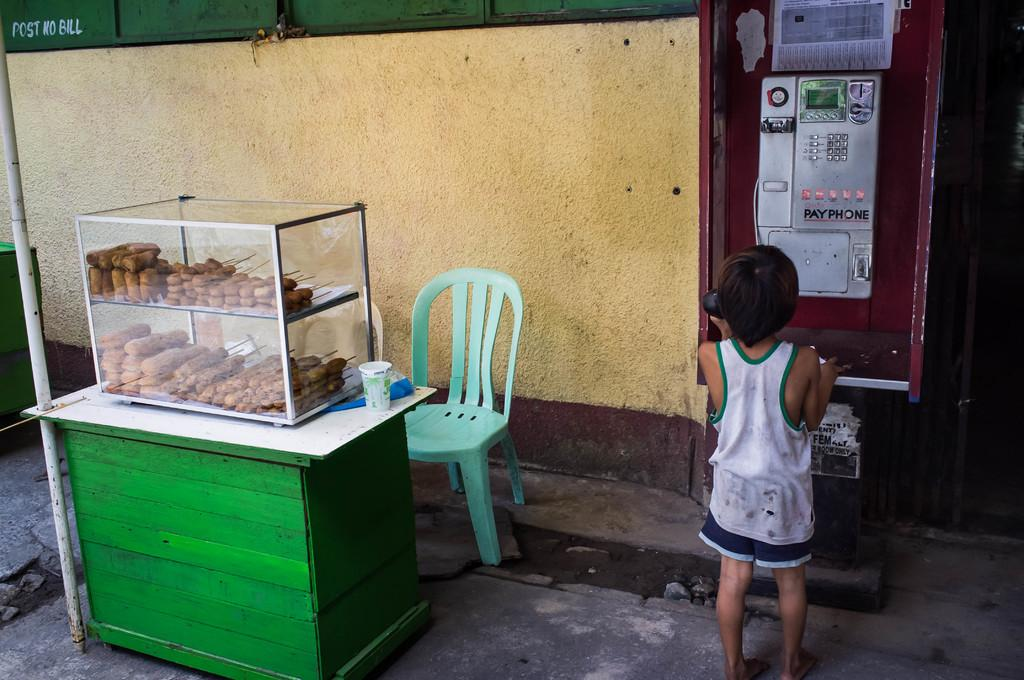What is the primary subject in the image? There is a person standing in the image. What else can be seen in the image besides the person? There are food items on a table and a chair in the image. Can you describe the chair in the image? The chair is green in color. Is the person swimming in the image? No, the person is not swimming in the image; they are standing. 